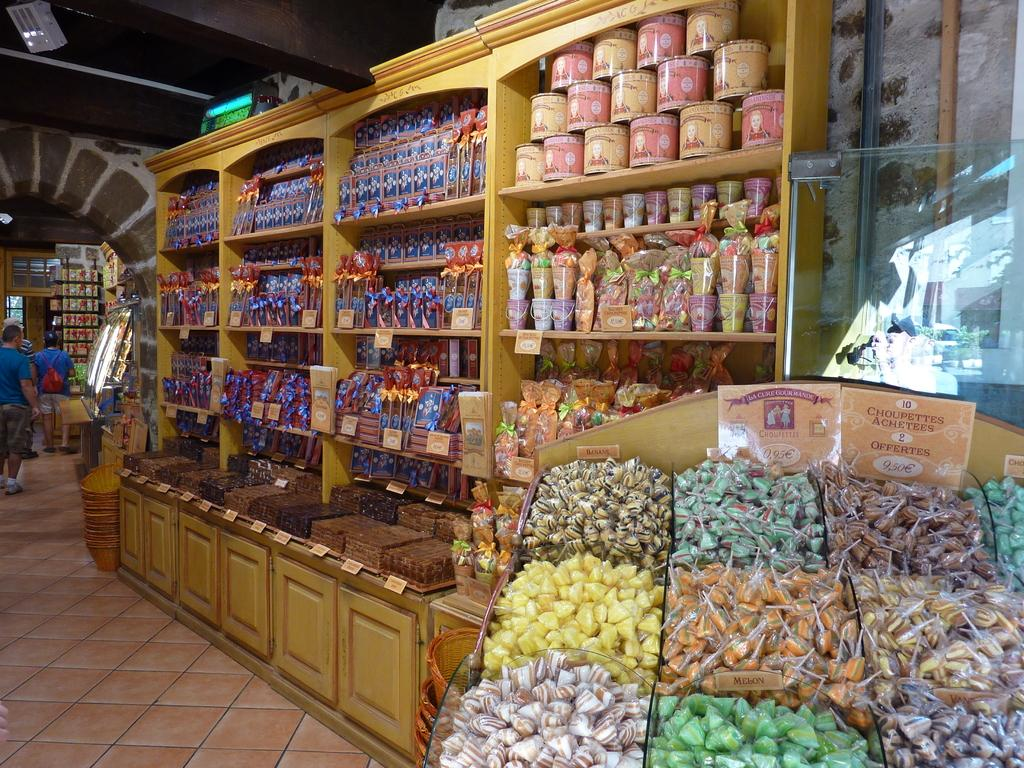What can be seen on the shelf in the image? Objects are arranged on a shelf in the image. Who or what is present in the image besides the objects on the shelf? There are people standing in the image. What part of the room can be seen at the bottom of the image? The floor is visible at the bottom of the image. What part of the room can be seen at the top of the image? The ceiling is visible at the top of the image. Where is the railway located in the image? There is no railway present in the image. What boundary is depicted in the image? There is no boundary depicted in the image. 